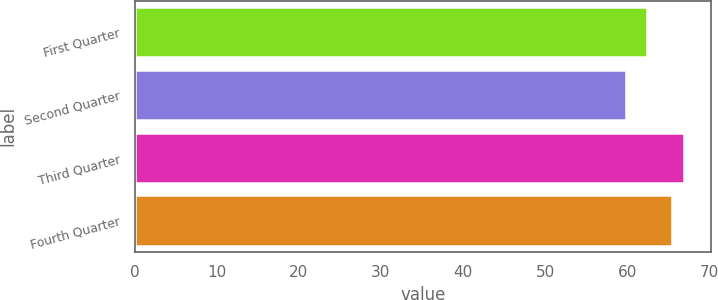Convert chart to OTSL. <chart><loc_0><loc_0><loc_500><loc_500><bar_chart><fcel>First Quarter<fcel>Second Quarter<fcel>Third Quarter<fcel>Fourth Quarter<nl><fcel>62.4<fcel>59.87<fcel>66.91<fcel>65.49<nl></chart> 